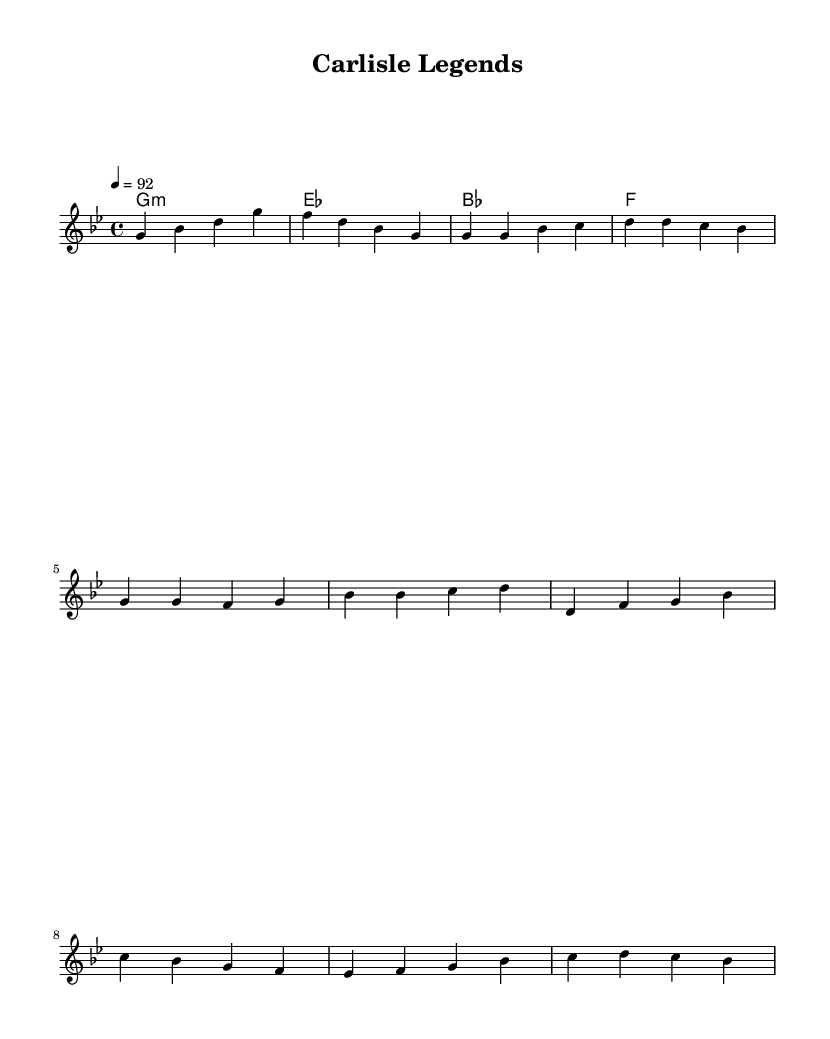What is the key signature of this music? The key signature is G minor, which has two flats (B flat and E flat). It can be identified in the beginning of the sheet music by looking at the key signature notations before the staff.
Answer: G minor What is the time signature of this music? The time signature is 4/4, indicating four beats per measure. This is evident at the start of the sheet music, where the time signature is specified.
Answer: 4/4 What is the tempo marking for this piece? The tempo marking is indicated as 92 beats per minute (BPM) on the sheet music and is found at the beginning near the tempo indication.
Answer: 92 How many measures are there in the chorus section? The chorus section consists of two measures. By counting the grouped notes and dividing into sections, we can see that these two measures contain the repeated phrases of the chorus.
Answer: 2 What type of chords are used in the harmonies section? The chords used are primarily triads, which consist of three notes. The chords indicated are G minor, E flat major, B flat major, and F major, identifiable in the chord mode section.
Answer: Triads What is the structure of the music in terms of sections? The structure includes an intro, chorus, and a verse. By analyzing the layout of the melody and the repeated sections in the sheet music, we can see that these distinct parts are clearly defined.
Answer: Intro, chorus, verse 